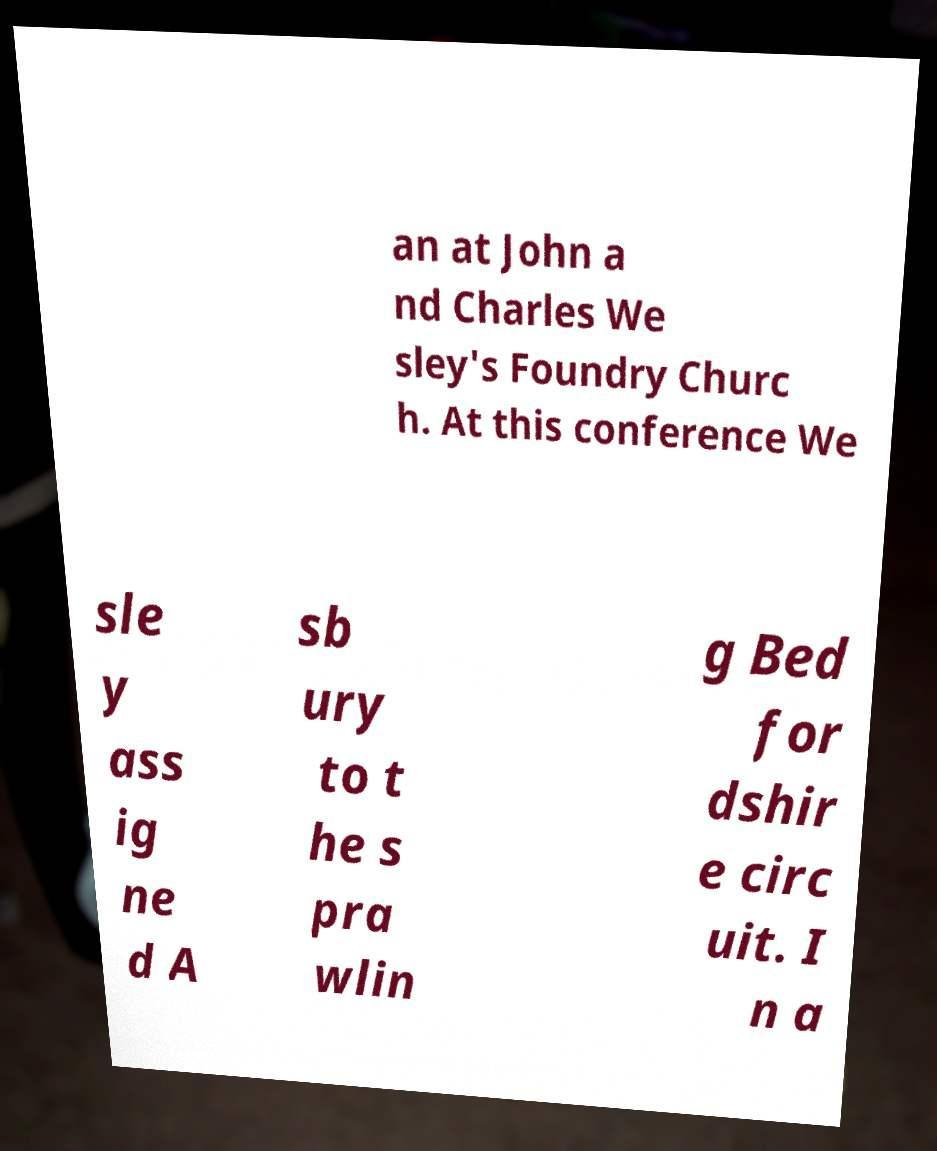I need the written content from this picture converted into text. Can you do that? an at John a nd Charles We sley's Foundry Churc h. At this conference We sle y ass ig ne d A sb ury to t he s pra wlin g Bed for dshir e circ uit. I n a 